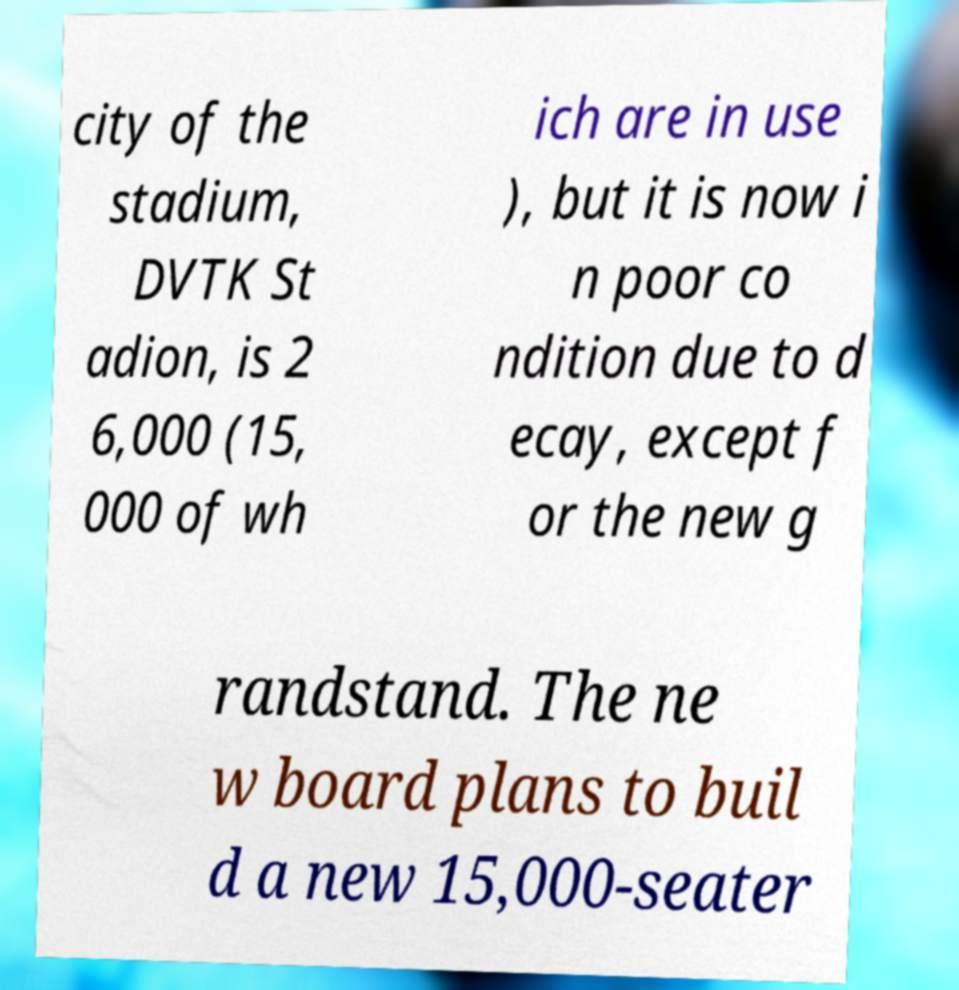There's text embedded in this image that I need extracted. Can you transcribe it verbatim? city of the stadium, DVTK St adion, is 2 6,000 (15, 000 of wh ich are in use ), but it is now i n poor co ndition due to d ecay, except f or the new g randstand. The ne w board plans to buil d a new 15,000-seater 